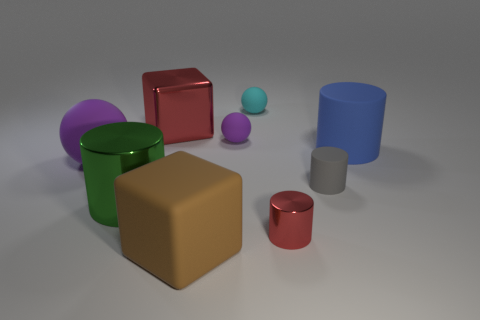Subtract all big blue matte cylinders. How many cylinders are left? 3 Subtract all purple spheres. How many spheres are left? 1 Subtract all cylinders. How many objects are left? 5 Subtract 2 cylinders. How many cylinders are left? 2 Subtract all yellow blocks. How many purple balls are left? 2 Subtract all brown metal balls. Subtract all large rubber cubes. How many objects are left? 8 Add 6 tiny purple rubber balls. How many tiny purple rubber balls are left? 7 Add 4 large blue rubber cylinders. How many large blue rubber cylinders exist? 5 Subtract 1 red cylinders. How many objects are left? 8 Subtract all cyan cylinders. Subtract all yellow balls. How many cylinders are left? 4 